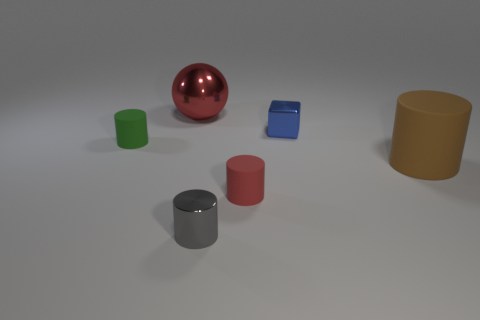Add 4 large rubber cylinders. How many objects exist? 10 Subtract all cylinders. How many objects are left? 2 Add 5 green matte cylinders. How many green matte cylinders are left? 6 Add 4 small blue cubes. How many small blue cubes exist? 5 Subtract 0 purple cylinders. How many objects are left? 6 Subtract all tiny gray metal things. Subtract all shiny objects. How many objects are left? 2 